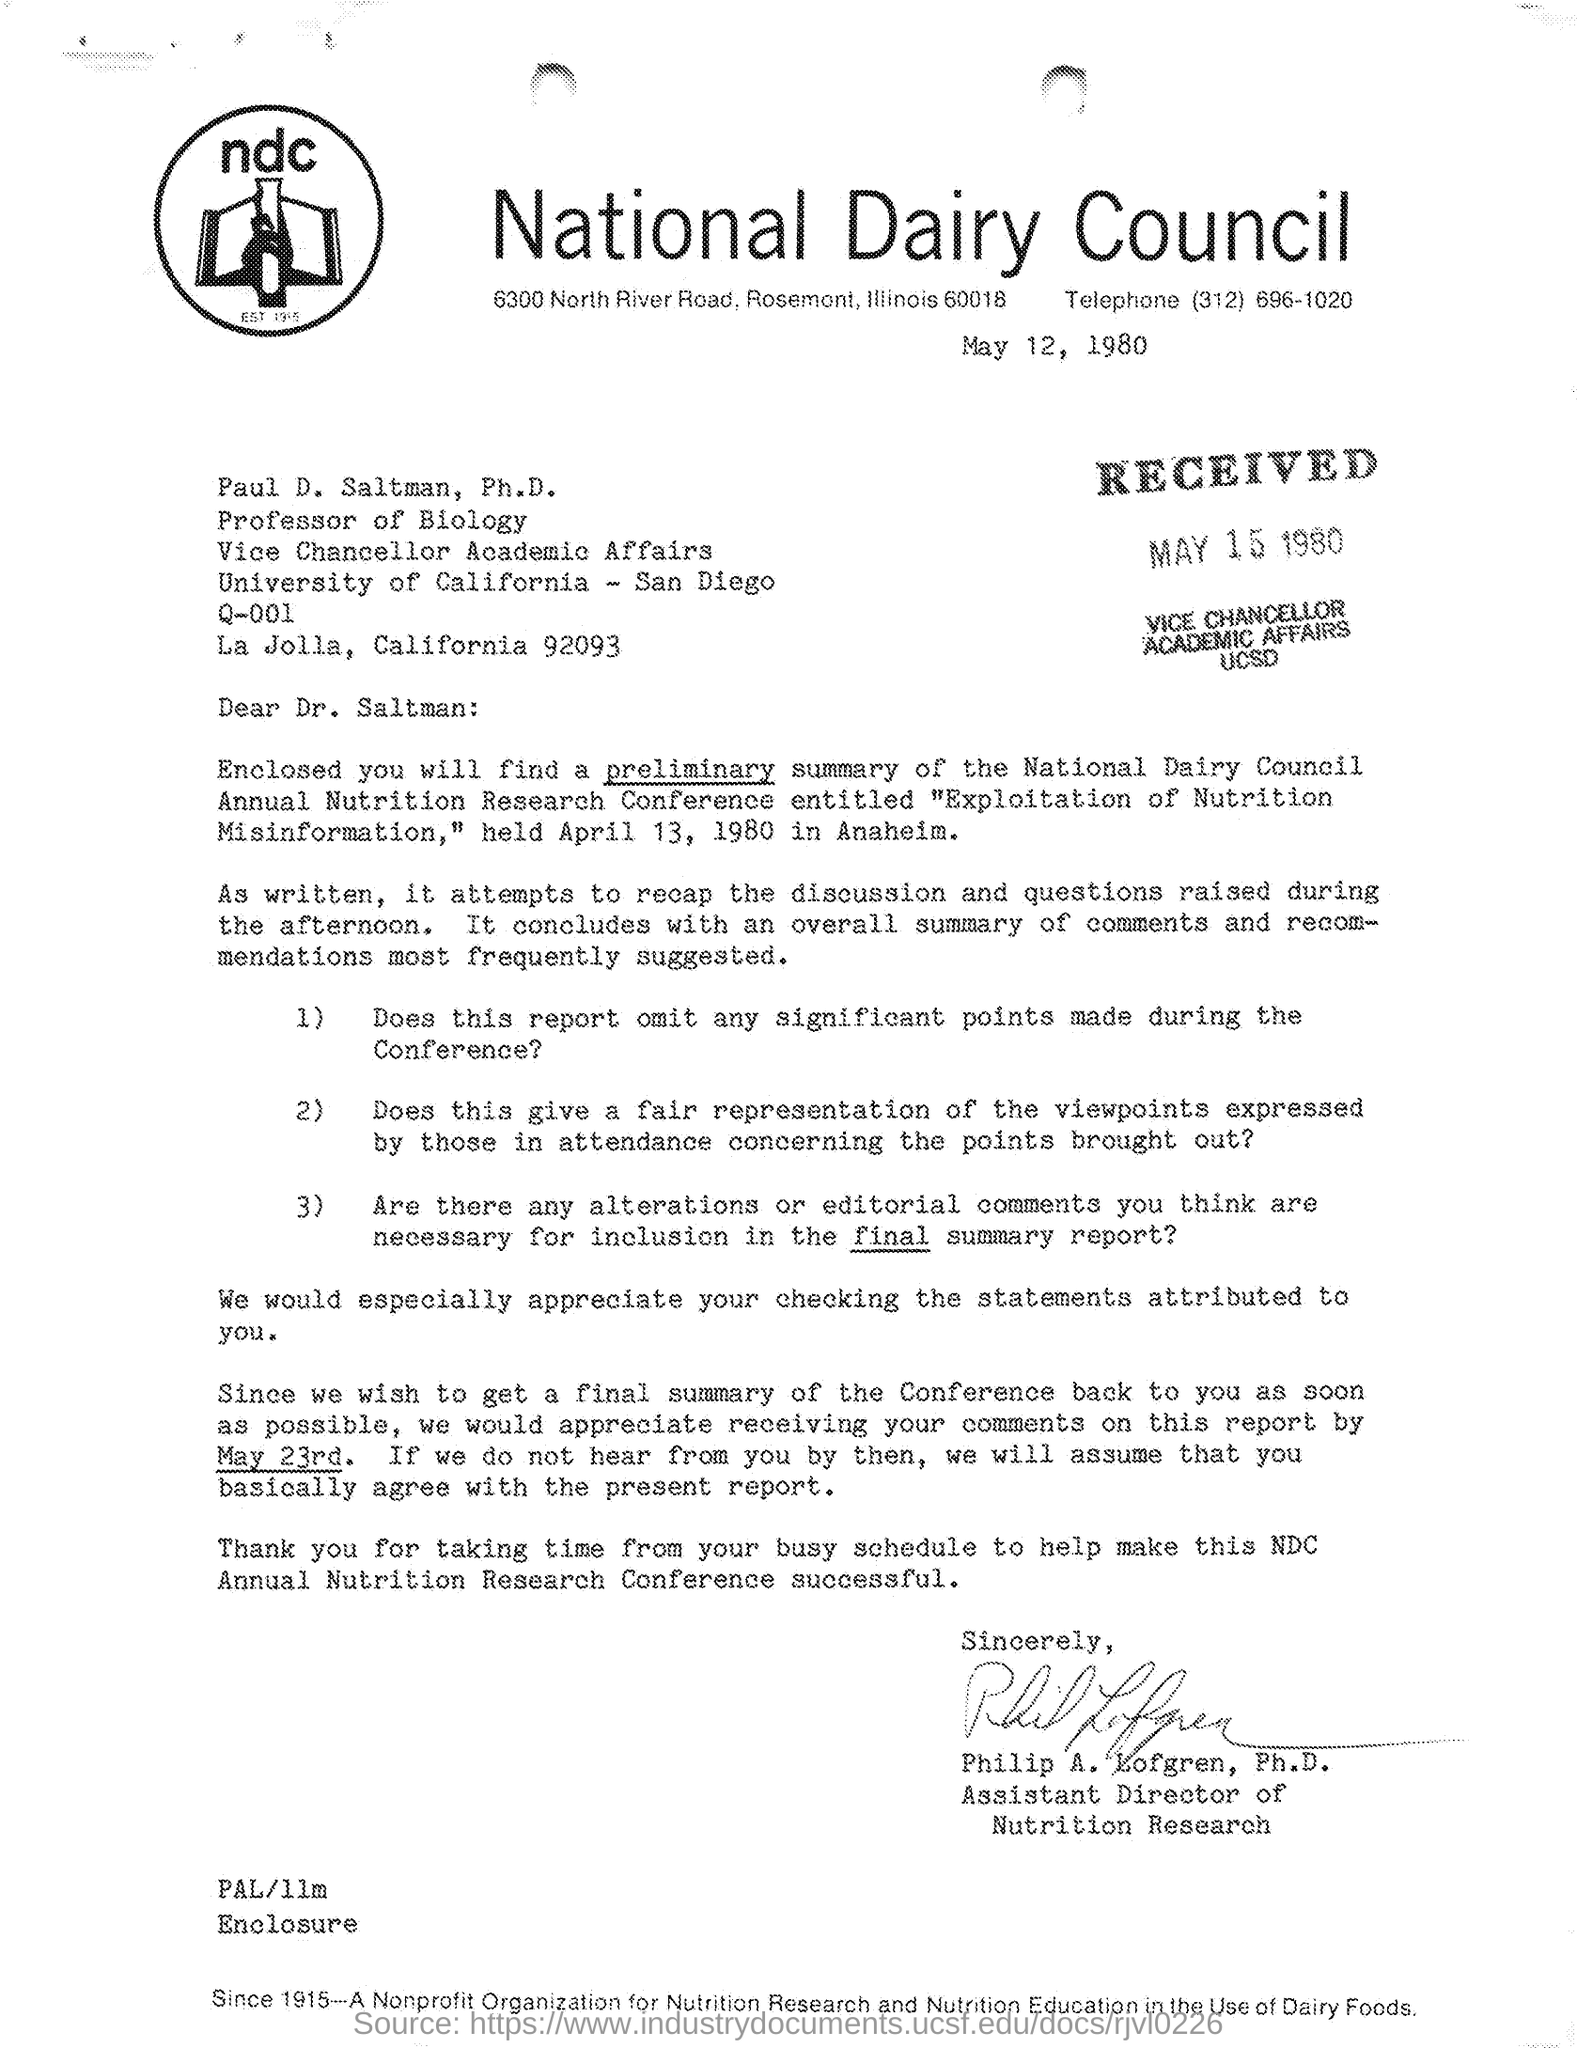List a handful of essential elements in this visual. The letter has been signed by Philip A. Lofgren. The received date of this letter is May 15, 1980. The Vice Chancellor of Academic Affairs at the University of California - San Diego is Paul D. Saltman, Ph.D. The issued date of the letter is May 12, 1980. The addressee of this letter is Paul D. Saltman, Ph.D., who is also referred to as Dr. Saltman. 